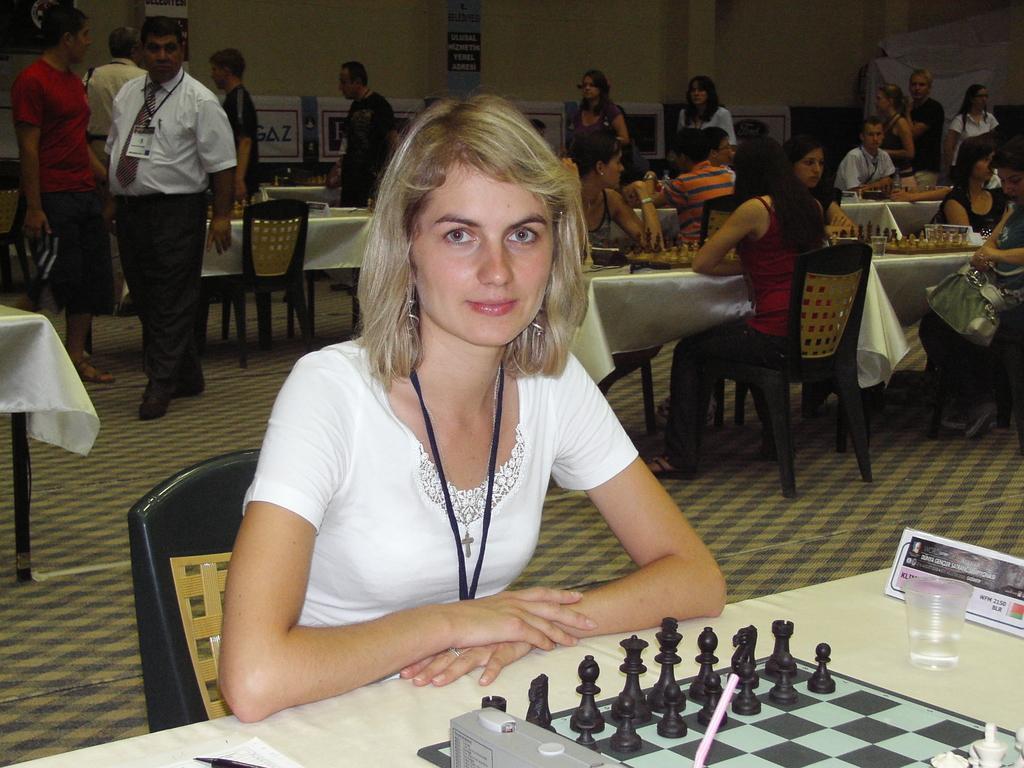Describe this image in one or two sentences. In this image we can see a girl is sitting on a black chair, she is wearing white top. In front of her one table is there, on table chess is present and one glass is there. Behind her so many people are sitting on table and they are playing chess and few people are moving. 